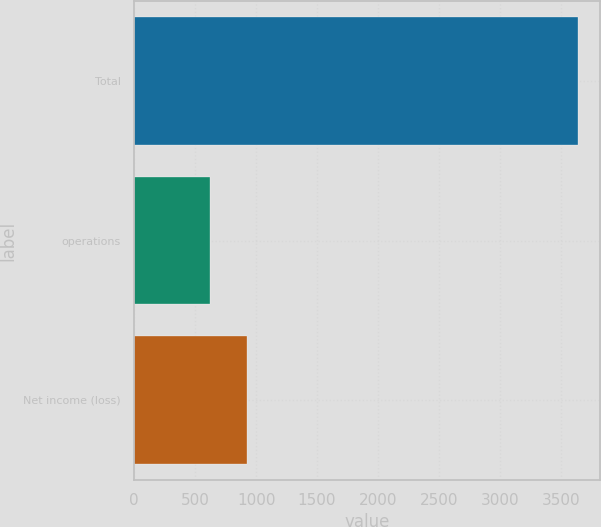<chart> <loc_0><loc_0><loc_500><loc_500><bar_chart><fcel>Total<fcel>operations<fcel>Net income (loss)<nl><fcel>3640.3<fcel>623.1<fcel>924.82<nl></chart> 